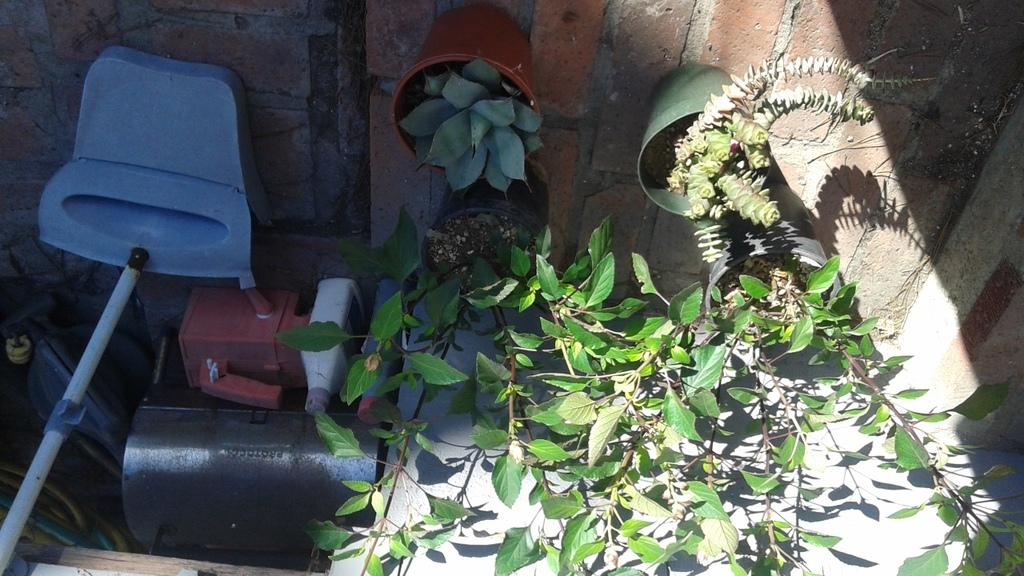What type of living organisms can be seen in the image? There are plants in pots in the image. What type of containers are visible in the image? There are bottles in the image. What color is the object in the image? There is a blue object in the image. What type of object is present in the image that can be used for support or guidance? There is a stick in the image. What is visible beneath the plants and bottles in the image? The ground is visible in the image. What type of structure can be seen in the background of the image? There is a wall in the image. How many giants are visible in the image? There are no giants present in the image. What direction is the wind blowing in the image? There is no indication of wind in the image. 